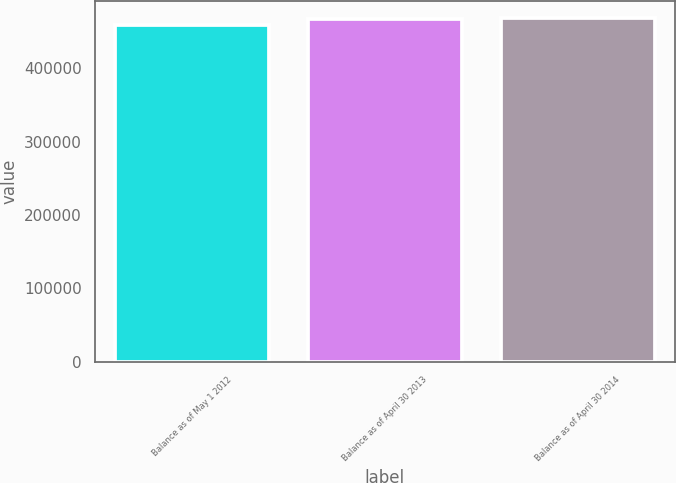Convert chart to OTSL. <chart><loc_0><loc_0><loc_500><loc_500><bar_chart><fcel>Balance as of May 1 2012<fcel>Balance as of April 30 2013<fcel>Balance as of April 30 2014<nl><fcel>459863<fcel>467079<fcel>468414<nl></chart> 